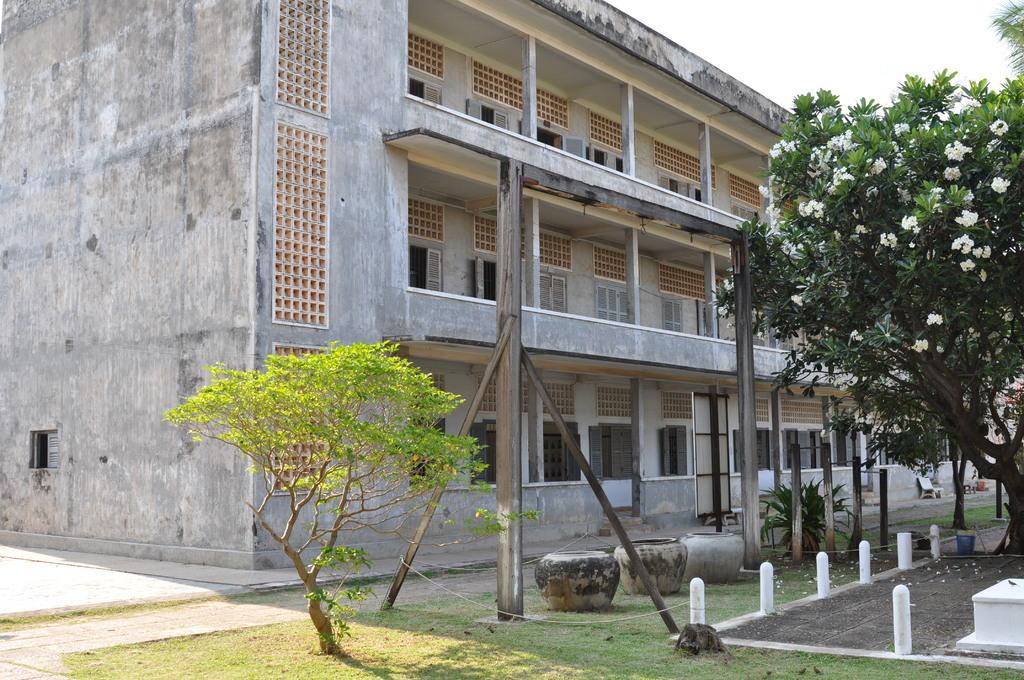What type of objects can be seen in the image that are made of wood? There are wooden poles in the image. What type of natural elements are present in the image? There are trees and a plant in the image. What type of structure can be seen in the image? There is a building in the image. What type of seating is available in the image? There is a bench in the image. What can be observed about the lighting in the image? Shadows are visible in the image. What type of bean is growing on the bench in the image? There are no beans present in the image, and the bench is not a suitable location for bean growth. 